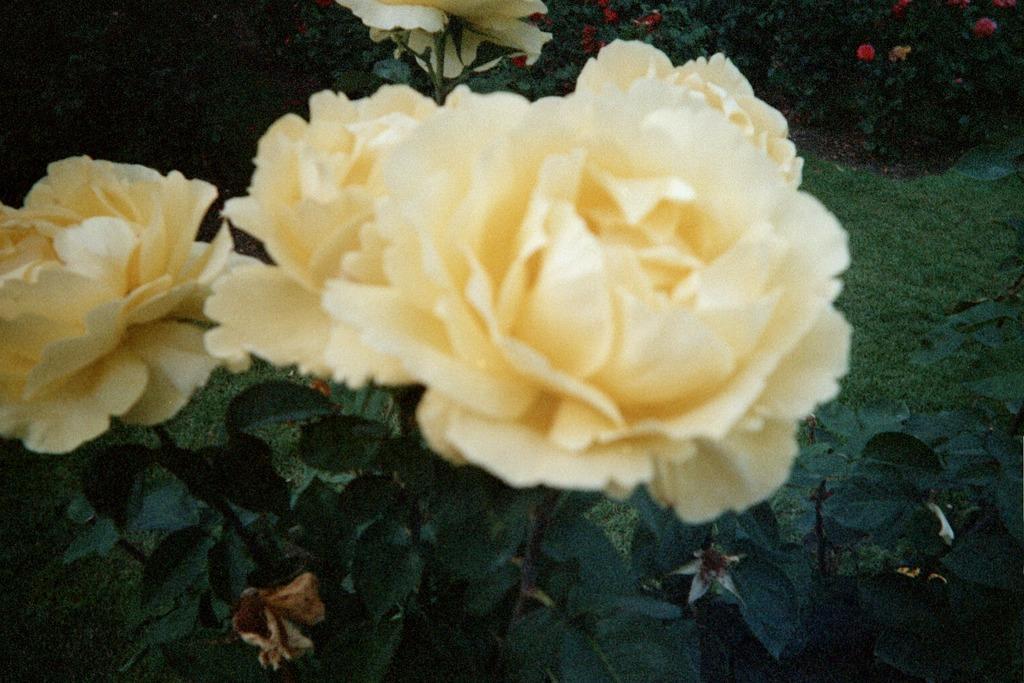Could you give a brief overview of what you see in this image? In this image I can see rose flowers and rose plant and leaves visible on the garden, in the background I can see plants. 